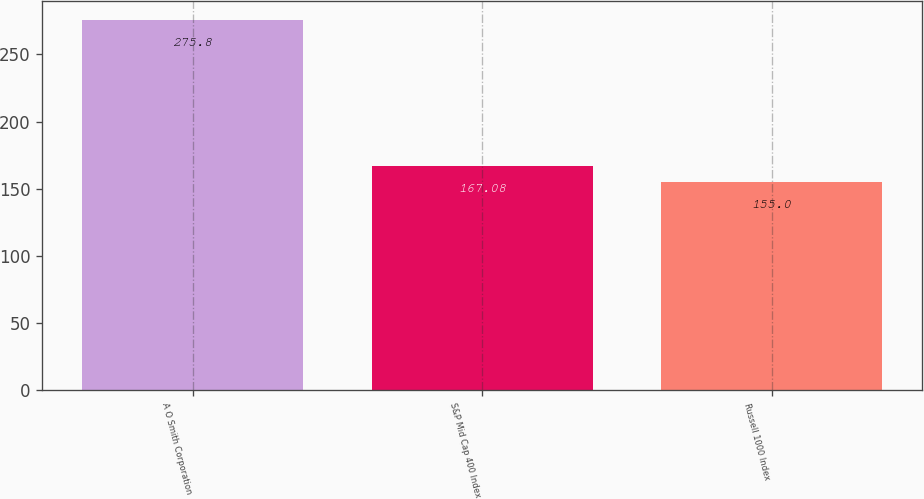Convert chart to OTSL. <chart><loc_0><loc_0><loc_500><loc_500><bar_chart><fcel>A O Smith Corporation<fcel>S&P Mid Cap 400 Index<fcel>Russell 1000 Index<nl><fcel>275.8<fcel>167.08<fcel>155<nl></chart> 